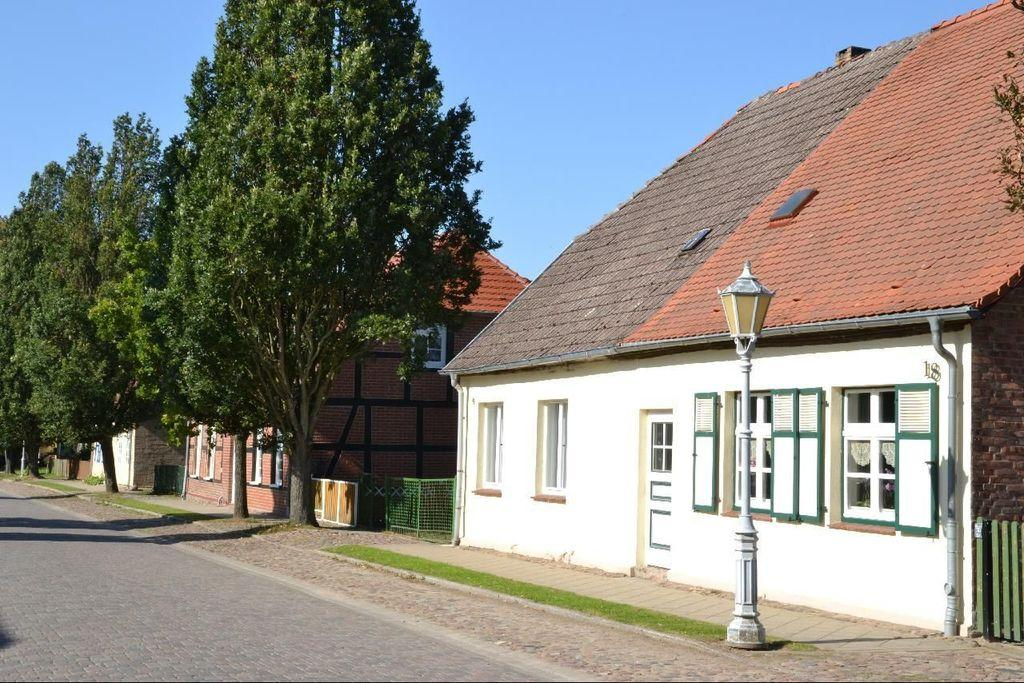What type of structures can be seen in the image? There are houses in the image. What other natural elements are present in the image? There are trees in the image. What connects the houses in the image? There is a road in front of the houses. What type of animal can be seen judging the houses in the image? There is no animal present in the image, let alone one that is judging the houses. 